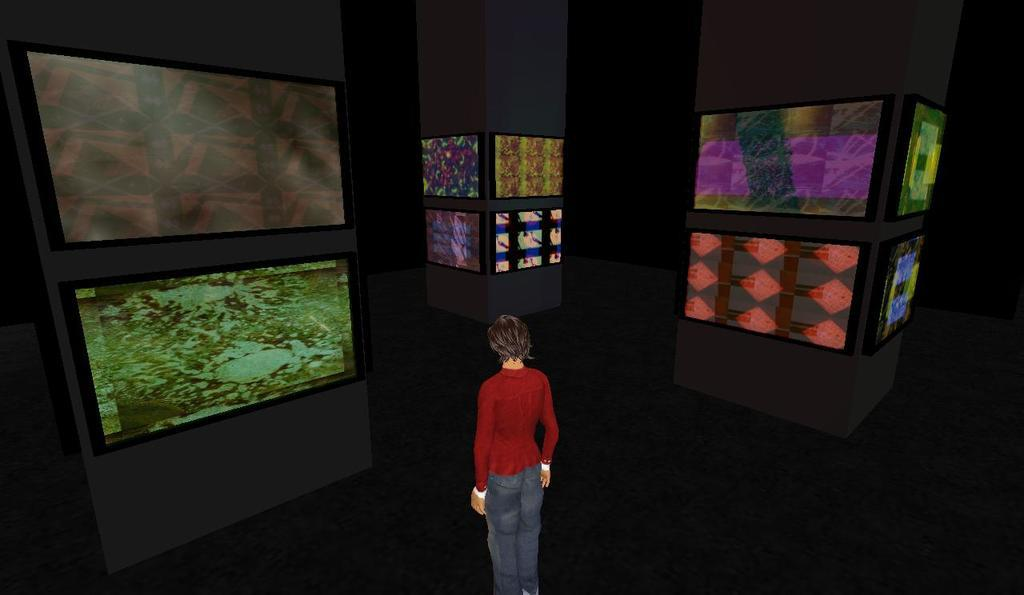What type of image is being described? The image is animated. Can you describe the person in the image? The person in the image is standing and wearing a maroon t-shirt and jeans. What can be seen in the background of the image? There are frames visible in the background of the image. What type of men were discovered in the image? There is no mention of men or any discovery in the image; it features an animated person wearing a maroon t-shirt and jeans, with frames visible in the background. What type of carriage is being pulled by the person in the image? There is no carriage present in the image; it only features a person standing and wearing specific clothing, with frames visible in the background. 